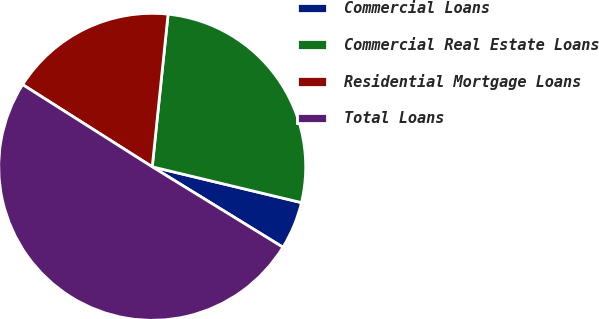<chart> <loc_0><loc_0><loc_500><loc_500><pie_chart><fcel>Commercial Loans<fcel>Commercial Real Estate Loans<fcel>Residential Mortgage Loans<fcel>Total Loans<nl><fcel>5.03%<fcel>27.1%<fcel>17.65%<fcel>50.22%<nl></chart> 